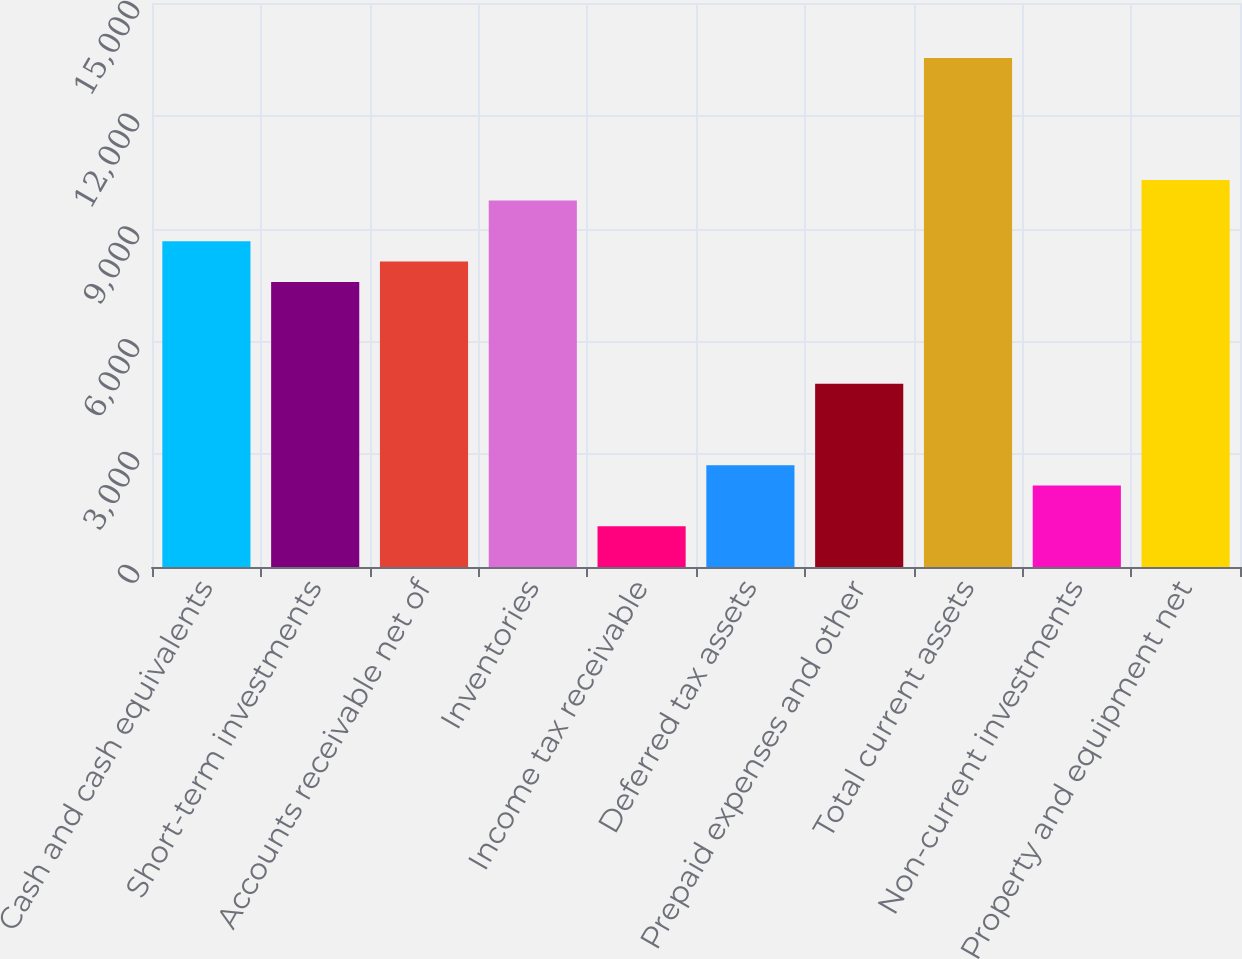Convert chart to OTSL. <chart><loc_0><loc_0><loc_500><loc_500><bar_chart><fcel>Cash and cash equivalents<fcel>Short-term investments<fcel>Accounts receivable net of<fcel>Inventories<fcel>Income tax receivable<fcel>Deferred tax assets<fcel>Prepaid expenses and other<fcel>Total current assets<fcel>Non-current investments<fcel>Property and equipment net<nl><fcel>8666.06<fcel>7582.84<fcel>8124.45<fcel>9749.28<fcel>1083.52<fcel>2708.35<fcel>4874.79<fcel>13540.5<fcel>2166.74<fcel>10290.9<nl></chart> 